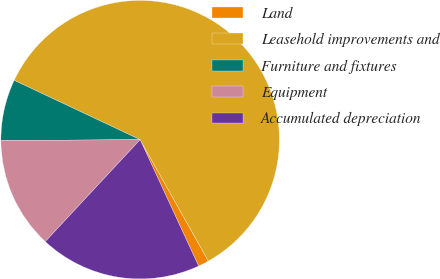<chart> <loc_0><loc_0><loc_500><loc_500><pie_chart><fcel>Land<fcel>Leasehold improvements and<fcel>Furniture and fixtures<fcel>Equipment<fcel>Accumulated depreciation<nl><fcel>1.25%<fcel>59.85%<fcel>7.11%<fcel>12.97%<fcel>18.83%<nl></chart> 